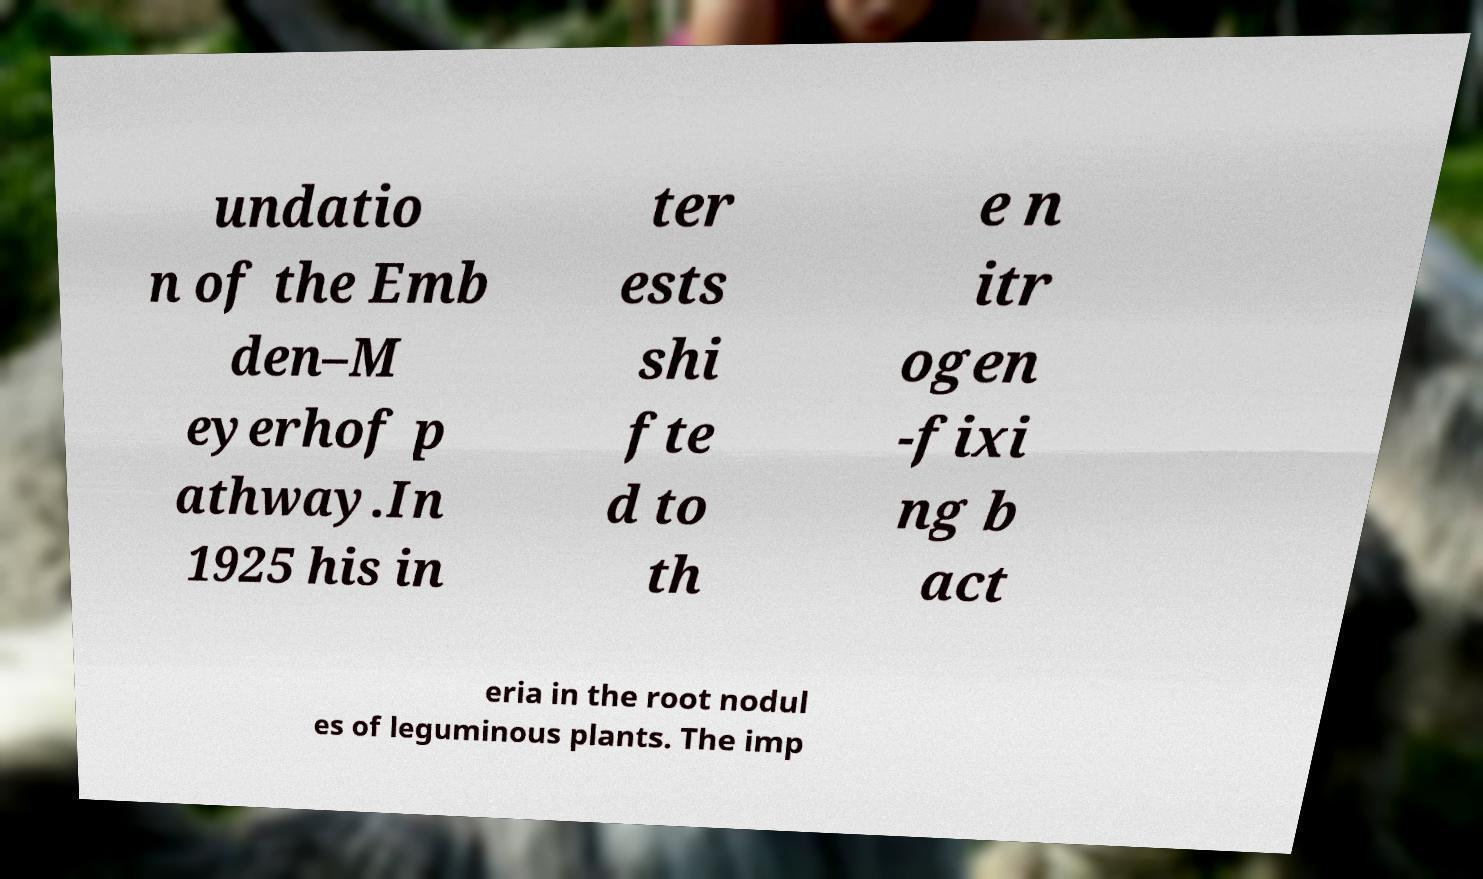Could you assist in decoding the text presented in this image and type it out clearly? undatio n of the Emb den–M eyerhof p athway.In 1925 his in ter ests shi fte d to th e n itr ogen -fixi ng b act eria in the root nodul es of leguminous plants. The imp 